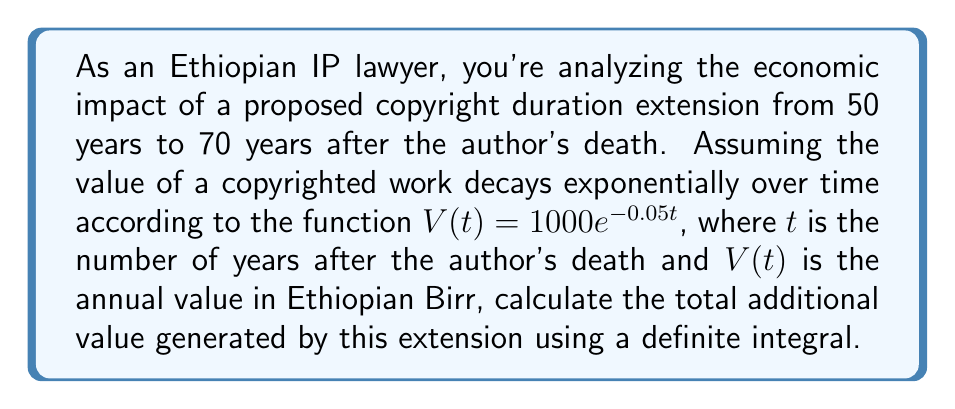Could you help me with this problem? To solve this problem, we need to follow these steps:

1) The function describing the annual value of the copyrighted work is:
   $V(t) = 1000e^{-0.05t}$

2) We need to calculate the difference between two definite integrals:
   - The integral from 50 to 70 years (the extension period)
   - The integral from 50 to infinity (the value that would have entered the public domain)

3) Let's calculate the integral from 50 to 70:

   $$\int_{50}^{70} 1000e^{-0.05t} dt$$

   $$= -20000e^{-0.05t}\Big|_{50}^{70}$$
   
   $$= -20000(e^{-3.5} - e^{-2.5})$$
   
   $$\approx 4060.58$$

4) Now, let's calculate the integral from 50 to infinity:

   $$\int_{50}^{\infty} 1000e^{-0.05t} dt$$

   $$= -20000e^{-0.05t}\Big|_{50}^{\infty}$$
   
   $$= -20000(0 - e^{-2.5})$$
   
   $$\approx 5709.40$$

5) The difference between these two integrals represents the value that would have entered the public domain but is now retained due to the extension:

   $5709.40 - 4060.58 = 1648.82$

Therefore, the additional value generated by the copyright extension is approximately 1648.82 Ethiopian Birr.
Answer: 1648.82 Ethiopian Birr 